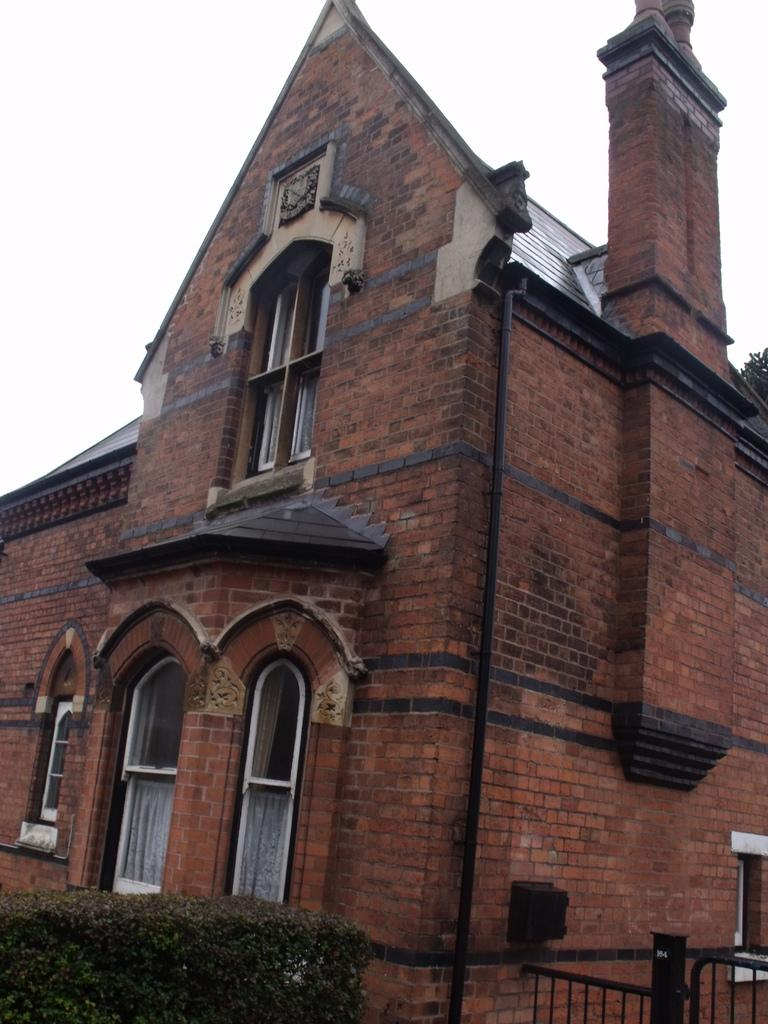What type of building is in the image? There is a building with red bricks in the image. What can be seen in front of the building? There are trees in front of the building. What is visible in the background of the image? The sky is visible in the background of the image. What type of music can be heard coming from the ocean in the image? There is no ocean present in the image, so it's not possible to determine what, if any, music might be heard. 